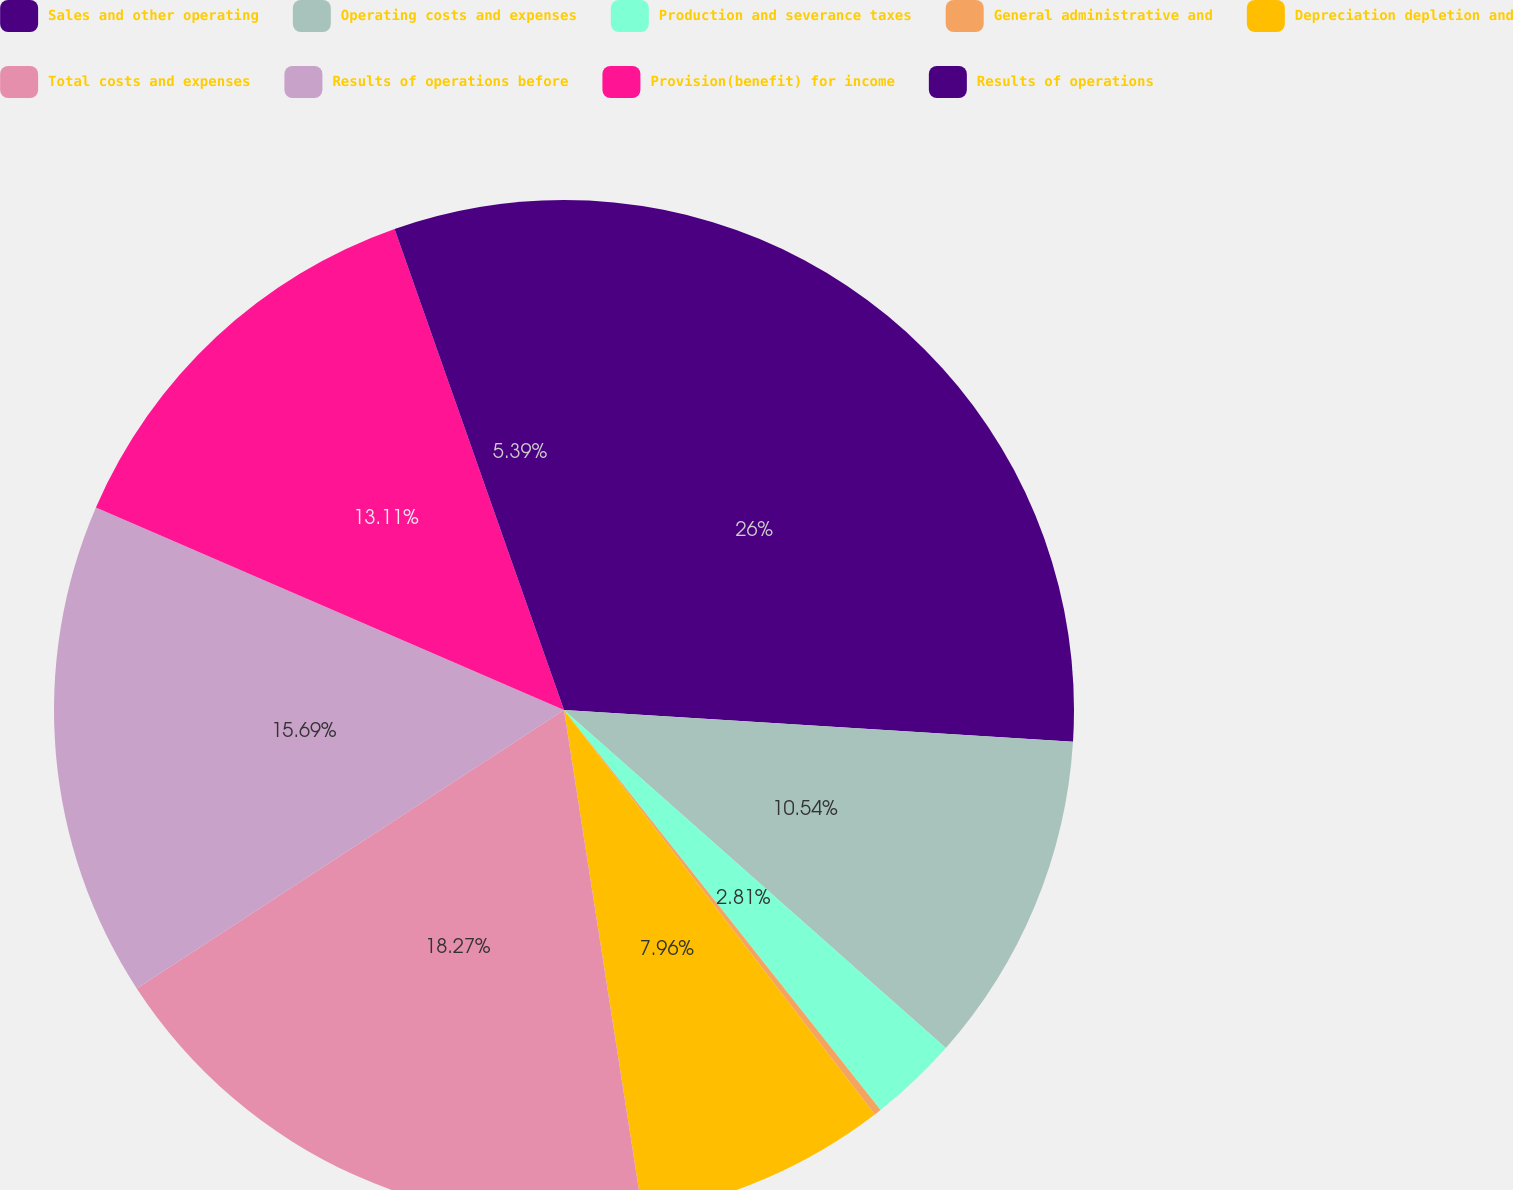Convert chart to OTSL. <chart><loc_0><loc_0><loc_500><loc_500><pie_chart><fcel>Sales and other operating<fcel>Operating costs and expenses<fcel>Production and severance taxes<fcel>General administrative and<fcel>Depreciation depletion and<fcel>Total costs and expenses<fcel>Results of operations before<fcel>Provision(benefit) for income<fcel>Results of operations<nl><fcel>25.99%<fcel>10.54%<fcel>2.81%<fcel>0.23%<fcel>7.96%<fcel>18.27%<fcel>15.69%<fcel>13.11%<fcel>5.39%<nl></chart> 